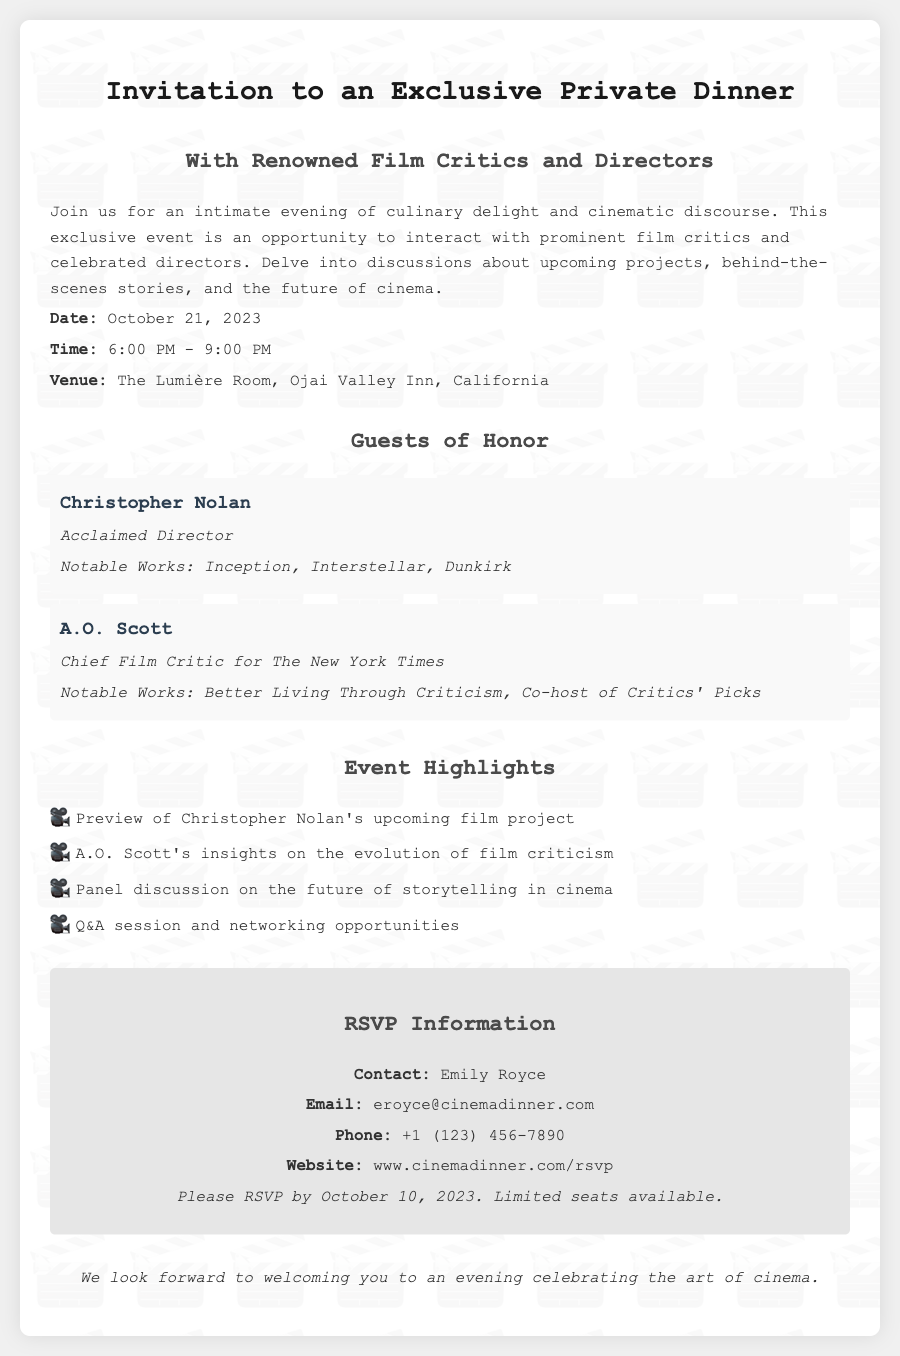what is the date of the event? The date of the event is explicitly stated in the invitation as October 21, 2023.
Answer: October 21, 2023 what is the time duration of the dinner? The time is mentioned in the document as starting at 6:00 PM and ending at 9:00 PM, making the duration three hours.
Answer: 6:00 PM - 9:00 PM who is one of the guests of honor? The document lists notable guests and Christopher Nolan is mentioned as one of them.
Answer: Christopher Nolan what is the venue for the dinner? The venue is clearly indicated in the document, which states it will be held at The Lumière Room, Ojai Valley Inn, California.
Answer: The Lumière Room, Ojai Valley Inn, California who is the contact person for the RSVP? The RSVP section of the document identifies Emily Royce as the contact for the event.
Answer: Emily Royce what is the deadline to RSVP? The RSVP information in the document specifies that responses should be received by October 10, 2023.
Answer: October 10, 2023 what type of discussion is mentioned as a highlight of the event? The event highlights indicate that there will be a panel discussion on the future of storytelling in cinema.
Answer: Future of storytelling in cinema how many notable works are listed for A.O. Scott? The section regarding guests lists two notable works for A.O. Scott.
Answer: Two what is the email address for the RSVP? The RSVP section provides eroyce@cinemadinner.com as the email address for attendees to respond.
Answer: eroyce@cinemadinner.com 